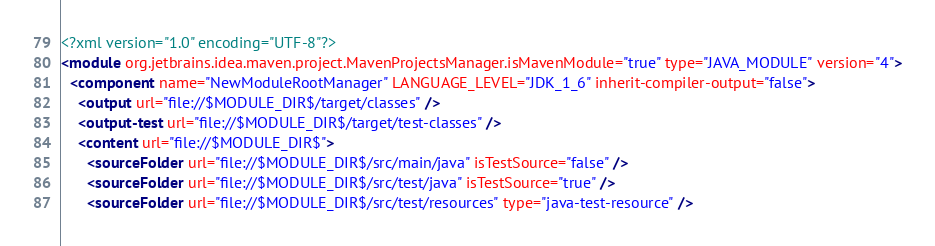<code> <loc_0><loc_0><loc_500><loc_500><_XML_><?xml version="1.0" encoding="UTF-8"?>
<module org.jetbrains.idea.maven.project.MavenProjectsManager.isMavenModule="true" type="JAVA_MODULE" version="4">
  <component name="NewModuleRootManager" LANGUAGE_LEVEL="JDK_1_6" inherit-compiler-output="false">
    <output url="file://$MODULE_DIR$/target/classes" />
    <output-test url="file://$MODULE_DIR$/target/test-classes" />
    <content url="file://$MODULE_DIR$">
      <sourceFolder url="file://$MODULE_DIR$/src/main/java" isTestSource="false" />
      <sourceFolder url="file://$MODULE_DIR$/src/test/java" isTestSource="true" />
      <sourceFolder url="file://$MODULE_DIR$/src/test/resources" type="java-test-resource" /></code> 